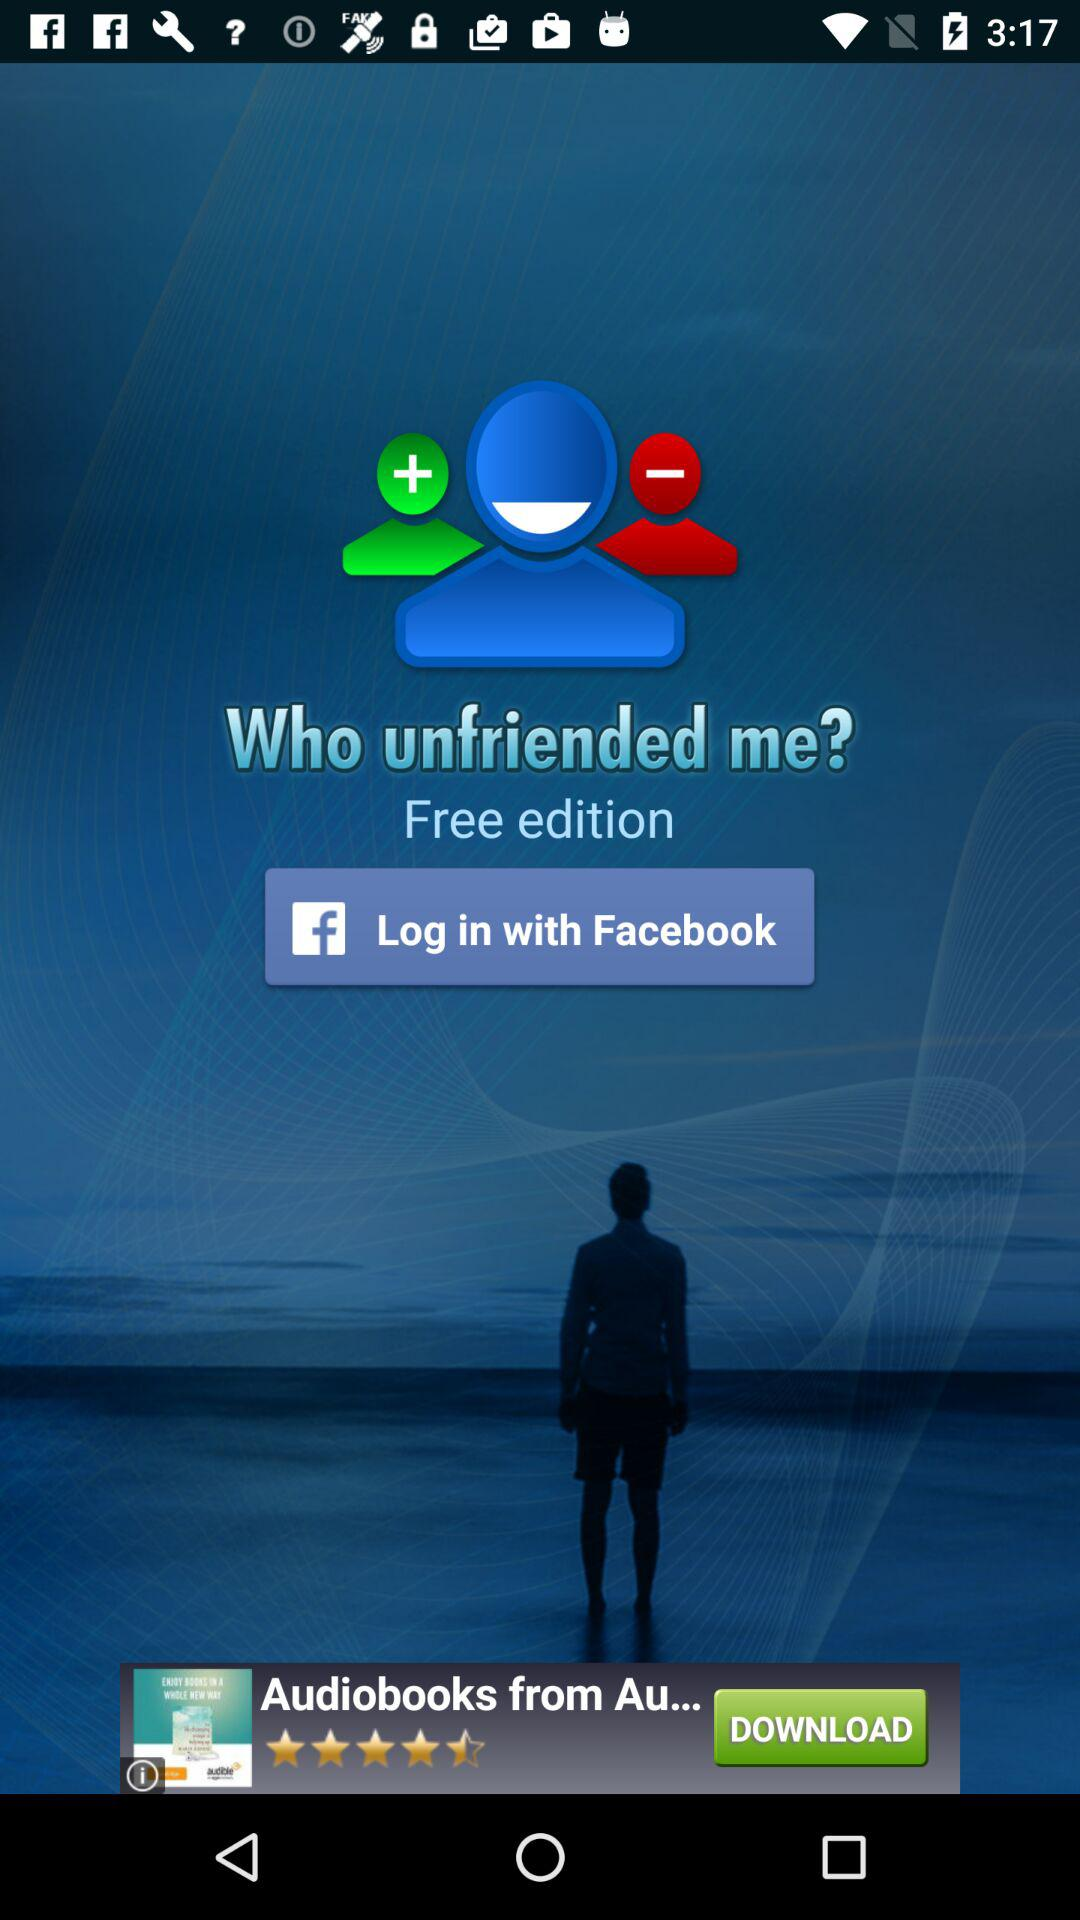Through what application can the user log in? The user can log in through "Facebook". 